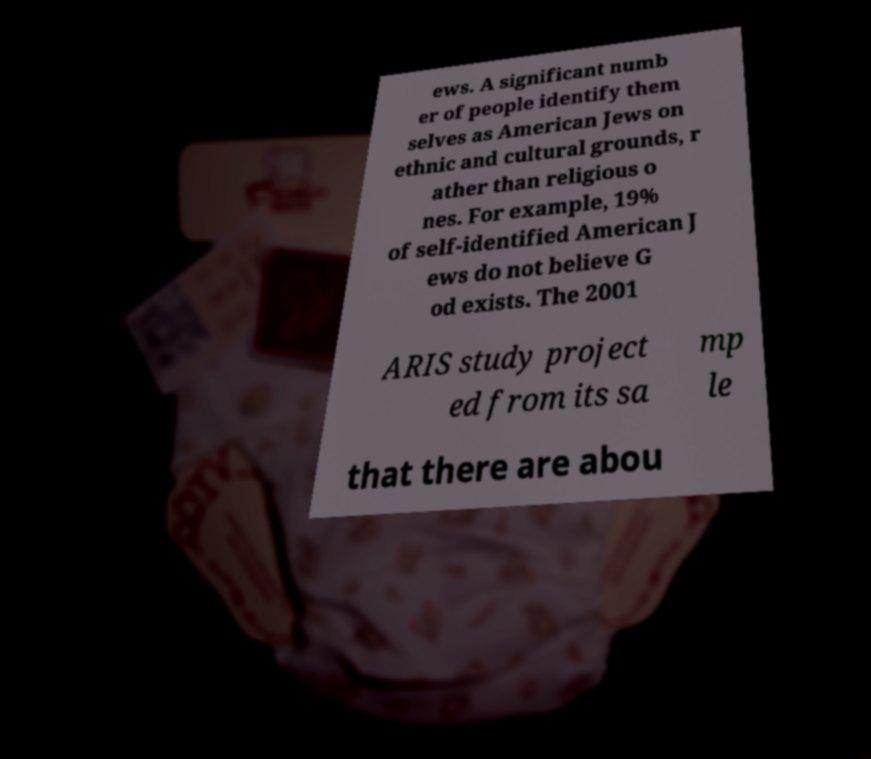I need the written content from this picture converted into text. Can you do that? ews. A significant numb er of people identify them selves as American Jews on ethnic and cultural grounds, r ather than religious o nes. For example, 19% of self-identified American J ews do not believe G od exists. The 2001 ARIS study project ed from its sa mp le that there are abou 